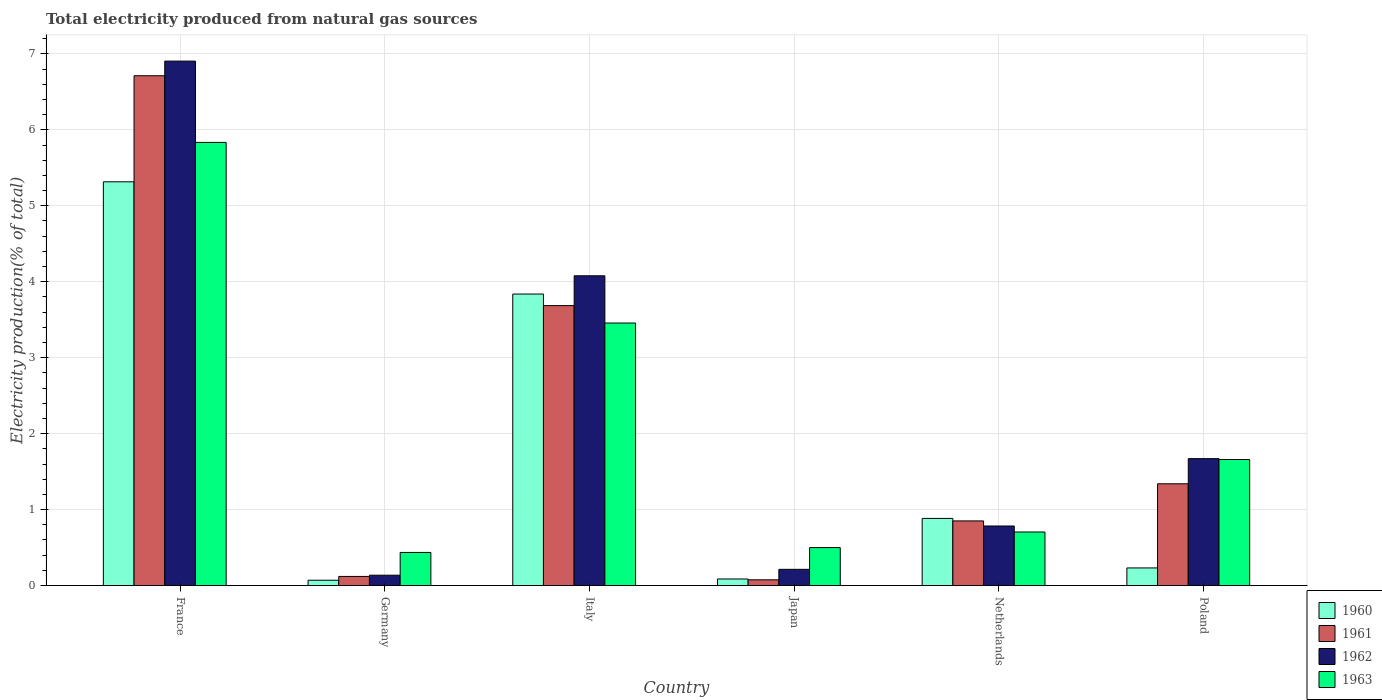How many different coloured bars are there?
Offer a very short reply. 4. Are the number of bars per tick equal to the number of legend labels?
Offer a terse response. Yes. How many bars are there on the 5th tick from the left?
Your response must be concise. 4. How many bars are there on the 1st tick from the right?
Provide a succinct answer. 4. What is the label of the 1st group of bars from the left?
Provide a succinct answer. France. In how many cases, is the number of bars for a given country not equal to the number of legend labels?
Provide a short and direct response. 0. What is the total electricity produced in 1963 in Poland?
Offer a very short reply. 1.66. Across all countries, what is the maximum total electricity produced in 1961?
Provide a short and direct response. 6.71. Across all countries, what is the minimum total electricity produced in 1961?
Provide a succinct answer. 0.08. What is the total total electricity produced in 1961 in the graph?
Provide a succinct answer. 12.78. What is the difference between the total electricity produced in 1960 in Italy and that in Japan?
Offer a terse response. 3.75. What is the difference between the total electricity produced in 1961 in Netherlands and the total electricity produced in 1963 in Germany?
Offer a very short reply. 0.41. What is the average total electricity produced in 1962 per country?
Give a very brief answer. 2.3. What is the difference between the total electricity produced of/in 1960 and total electricity produced of/in 1963 in Italy?
Your answer should be compact. 0.38. In how many countries, is the total electricity produced in 1961 greater than 5 %?
Make the answer very short. 1. What is the ratio of the total electricity produced in 1960 in Germany to that in Japan?
Make the answer very short. 0.81. Is the difference between the total electricity produced in 1960 in Japan and Poland greater than the difference between the total electricity produced in 1963 in Japan and Poland?
Keep it short and to the point. Yes. What is the difference between the highest and the second highest total electricity produced in 1961?
Keep it short and to the point. -2.35. What is the difference between the highest and the lowest total electricity produced in 1963?
Your answer should be compact. 5.4. In how many countries, is the total electricity produced in 1961 greater than the average total electricity produced in 1961 taken over all countries?
Your answer should be very brief. 2. Is the sum of the total electricity produced in 1961 in France and Germany greater than the maximum total electricity produced in 1960 across all countries?
Provide a short and direct response. Yes. Is it the case that in every country, the sum of the total electricity produced in 1962 and total electricity produced in 1961 is greater than the sum of total electricity produced in 1960 and total electricity produced in 1963?
Ensure brevity in your answer.  No. What does the 1st bar from the right in France represents?
Your answer should be very brief. 1963. Is it the case that in every country, the sum of the total electricity produced in 1963 and total electricity produced in 1960 is greater than the total electricity produced in 1961?
Offer a very short reply. Yes. How many bars are there?
Give a very brief answer. 24. Are all the bars in the graph horizontal?
Give a very brief answer. No. Does the graph contain grids?
Your answer should be compact. Yes. Where does the legend appear in the graph?
Give a very brief answer. Bottom right. How many legend labels are there?
Offer a very short reply. 4. What is the title of the graph?
Make the answer very short. Total electricity produced from natural gas sources. Does "1961" appear as one of the legend labels in the graph?
Ensure brevity in your answer.  Yes. What is the label or title of the Y-axis?
Offer a terse response. Electricity production(% of total). What is the Electricity production(% of total) of 1960 in France?
Your response must be concise. 5.32. What is the Electricity production(% of total) of 1961 in France?
Offer a terse response. 6.71. What is the Electricity production(% of total) in 1962 in France?
Offer a terse response. 6.91. What is the Electricity production(% of total) of 1963 in France?
Provide a short and direct response. 5.83. What is the Electricity production(% of total) in 1960 in Germany?
Provide a succinct answer. 0.07. What is the Electricity production(% of total) in 1961 in Germany?
Keep it short and to the point. 0.12. What is the Electricity production(% of total) in 1962 in Germany?
Offer a very short reply. 0.14. What is the Electricity production(% of total) of 1963 in Germany?
Keep it short and to the point. 0.44. What is the Electricity production(% of total) of 1960 in Italy?
Keep it short and to the point. 3.84. What is the Electricity production(% of total) in 1961 in Italy?
Your response must be concise. 3.69. What is the Electricity production(% of total) in 1962 in Italy?
Offer a terse response. 4.08. What is the Electricity production(% of total) in 1963 in Italy?
Make the answer very short. 3.46. What is the Electricity production(% of total) in 1960 in Japan?
Keep it short and to the point. 0.09. What is the Electricity production(% of total) in 1961 in Japan?
Provide a short and direct response. 0.08. What is the Electricity production(% of total) of 1962 in Japan?
Give a very brief answer. 0.21. What is the Electricity production(% of total) in 1963 in Japan?
Your answer should be compact. 0.5. What is the Electricity production(% of total) in 1960 in Netherlands?
Your answer should be very brief. 0.88. What is the Electricity production(% of total) of 1961 in Netherlands?
Provide a succinct answer. 0.85. What is the Electricity production(% of total) of 1962 in Netherlands?
Your answer should be compact. 0.78. What is the Electricity production(% of total) in 1963 in Netherlands?
Provide a short and direct response. 0.71. What is the Electricity production(% of total) of 1960 in Poland?
Offer a very short reply. 0.23. What is the Electricity production(% of total) in 1961 in Poland?
Give a very brief answer. 1.34. What is the Electricity production(% of total) of 1962 in Poland?
Keep it short and to the point. 1.67. What is the Electricity production(% of total) in 1963 in Poland?
Give a very brief answer. 1.66. Across all countries, what is the maximum Electricity production(% of total) of 1960?
Give a very brief answer. 5.32. Across all countries, what is the maximum Electricity production(% of total) of 1961?
Make the answer very short. 6.71. Across all countries, what is the maximum Electricity production(% of total) in 1962?
Your answer should be compact. 6.91. Across all countries, what is the maximum Electricity production(% of total) in 1963?
Provide a succinct answer. 5.83. Across all countries, what is the minimum Electricity production(% of total) in 1960?
Provide a short and direct response. 0.07. Across all countries, what is the minimum Electricity production(% of total) in 1961?
Provide a short and direct response. 0.08. Across all countries, what is the minimum Electricity production(% of total) in 1962?
Give a very brief answer. 0.14. Across all countries, what is the minimum Electricity production(% of total) in 1963?
Offer a very short reply. 0.44. What is the total Electricity production(% of total) of 1960 in the graph?
Offer a very short reply. 10.43. What is the total Electricity production(% of total) of 1961 in the graph?
Your answer should be very brief. 12.79. What is the total Electricity production(% of total) of 1962 in the graph?
Offer a very short reply. 13.79. What is the total Electricity production(% of total) in 1963 in the graph?
Offer a terse response. 12.59. What is the difference between the Electricity production(% of total) in 1960 in France and that in Germany?
Provide a succinct answer. 5.25. What is the difference between the Electricity production(% of total) in 1961 in France and that in Germany?
Your response must be concise. 6.59. What is the difference between the Electricity production(% of total) of 1962 in France and that in Germany?
Keep it short and to the point. 6.77. What is the difference between the Electricity production(% of total) of 1963 in France and that in Germany?
Your answer should be very brief. 5.4. What is the difference between the Electricity production(% of total) of 1960 in France and that in Italy?
Your response must be concise. 1.48. What is the difference between the Electricity production(% of total) of 1961 in France and that in Italy?
Keep it short and to the point. 3.03. What is the difference between the Electricity production(% of total) of 1962 in France and that in Italy?
Make the answer very short. 2.83. What is the difference between the Electricity production(% of total) in 1963 in France and that in Italy?
Offer a terse response. 2.38. What is the difference between the Electricity production(% of total) of 1960 in France and that in Japan?
Your answer should be compact. 5.23. What is the difference between the Electricity production(% of total) in 1961 in France and that in Japan?
Your answer should be very brief. 6.64. What is the difference between the Electricity production(% of total) in 1962 in France and that in Japan?
Ensure brevity in your answer.  6.69. What is the difference between the Electricity production(% of total) of 1963 in France and that in Japan?
Give a very brief answer. 5.33. What is the difference between the Electricity production(% of total) of 1960 in France and that in Netherlands?
Keep it short and to the point. 4.43. What is the difference between the Electricity production(% of total) of 1961 in France and that in Netherlands?
Make the answer very short. 5.86. What is the difference between the Electricity production(% of total) of 1962 in France and that in Netherlands?
Keep it short and to the point. 6.12. What is the difference between the Electricity production(% of total) in 1963 in France and that in Netherlands?
Your response must be concise. 5.13. What is the difference between the Electricity production(% of total) in 1960 in France and that in Poland?
Your answer should be very brief. 5.08. What is the difference between the Electricity production(% of total) in 1961 in France and that in Poland?
Keep it short and to the point. 5.37. What is the difference between the Electricity production(% of total) in 1962 in France and that in Poland?
Ensure brevity in your answer.  5.23. What is the difference between the Electricity production(% of total) of 1963 in France and that in Poland?
Your answer should be very brief. 4.18. What is the difference between the Electricity production(% of total) of 1960 in Germany and that in Italy?
Your response must be concise. -3.77. What is the difference between the Electricity production(% of total) in 1961 in Germany and that in Italy?
Keep it short and to the point. -3.57. What is the difference between the Electricity production(% of total) of 1962 in Germany and that in Italy?
Your answer should be compact. -3.94. What is the difference between the Electricity production(% of total) of 1963 in Germany and that in Italy?
Make the answer very short. -3.02. What is the difference between the Electricity production(% of total) in 1960 in Germany and that in Japan?
Ensure brevity in your answer.  -0.02. What is the difference between the Electricity production(% of total) of 1961 in Germany and that in Japan?
Provide a short and direct response. 0.04. What is the difference between the Electricity production(% of total) of 1962 in Germany and that in Japan?
Ensure brevity in your answer.  -0.08. What is the difference between the Electricity production(% of total) of 1963 in Germany and that in Japan?
Provide a succinct answer. -0.06. What is the difference between the Electricity production(% of total) of 1960 in Germany and that in Netherlands?
Provide a short and direct response. -0.81. What is the difference between the Electricity production(% of total) of 1961 in Germany and that in Netherlands?
Offer a very short reply. -0.73. What is the difference between the Electricity production(% of total) in 1962 in Germany and that in Netherlands?
Your answer should be very brief. -0.65. What is the difference between the Electricity production(% of total) in 1963 in Germany and that in Netherlands?
Offer a terse response. -0.27. What is the difference between the Electricity production(% of total) of 1960 in Germany and that in Poland?
Your answer should be compact. -0.16. What is the difference between the Electricity production(% of total) of 1961 in Germany and that in Poland?
Your answer should be very brief. -1.22. What is the difference between the Electricity production(% of total) of 1962 in Germany and that in Poland?
Provide a succinct answer. -1.53. What is the difference between the Electricity production(% of total) in 1963 in Germany and that in Poland?
Give a very brief answer. -1.22. What is the difference between the Electricity production(% of total) in 1960 in Italy and that in Japan?
Your answer should be very brief. 3.75. What is the difference between the Electricity production(% of total) in 1961 in Italy and that in Japan?
Your response must be concise. 3.61. What is the difference between the Electricity production(% of total) in 1962 in Italy and that in Japan?
Your response must be concise. 3.86. What is the difference between the Electricity production(% of total) in 1963 in Italy and that in Japan?
Offer a very short reply. 2.96. What is the difference between the Electricity production(% of total) of 1960 in Italy and that in Netherlands?
Give a very brief answer. 2.95. What is the difference between the Electricity production(% of total) of 1961 in Italy and that in Netherlands?
Give a very brief answer. 2.83. What is the difference between the Electricity production(% of total) of 1962 in Italy and that in Netherlands?
Keep it short and to the point. 3.29. What is the difference between the Electricity production(% of total) in 1963 in Italy and that in Netherlands?
Your answer should be very brief. 2.75. What is the difference between the Electricity production(% of total) in 1960 in Italy and that in Poland?
Give a very brief answer. 3.61. What is the difference between the Electricity production(% of total) of 1961 in Italy and that in Poland?
Keep it short and to the point. 2.35. What is the difference between the Electricity production(% of total) in 1962 in Italy and that in Poland?
Ensure brevity in your answer.  2.41. What is the difference between the Electricity production(% of total) of 1963 in Italy and that in Poland?
Give a very brief answer. 1.8. What is the difference between the Electricity production(% of total) in 1960 in Japan and that in Netherlands?
Offer a very short reply. -0.8. What is the difference between the Electricity production(% of total) in 1961 in Japan and that in Netherlands?
Provide a short and direct response. -0.78. What is the difference between the Electricity production(% of total) in 1962 in Japan and that in Netherlands?
Your response must be concise. -0.57. What is the difference between the Electricity production(% of total) of 1963 in Japan and that in Netherlands?
Offer a terse response. -0.21. What is the difference between the Electricity production(% of total) of 1960 in Japan and that in Poland?
Make the answer very short. -0.15. What is the difference between the Electricity production(% of total) of 1961 in Japan and that in Poland?
Give a very brief answer. -1.26. What is the difference between the Electricity production(% of total) in 1962 in Japan and that in Poland?
Your answer should be compact. -1.46. What is the difference between the Electricity production(% of total) in 1963 in Japan and that in Poland?
Give a very brief answer. -1.16. What is the difference between the Electricity production(% of total) of 1960 in Netherlands and that in Poland?
Give a very brief answer. 0.65. What is the difference between the Electricity production(% of total) of 1961 in Netherlands and that in Poland?
Give a very brief answer. -0.49. What is the difference between the Electricity production(% of total) in 1962 in Netherlands and that in Poland?
Offer a very short reply. -0.89. What is the difference between the Electricity production(% of total) of 1963 in Netherlands and that in Poland?
Keep it short and to the point. -0.95. What is the difference between the Electricity production(% of total) of 1960 in France and the Electricity production(% of total) of 1961 in Germany?
Your response must be concise. 5.2. What is the difference between the Electricity production(% of total) of 1960 in France and the Electricity production(% of total) of 1962 in Germany?
Give a very brief answer. 5.18. What is the difference between the Electricity production(% of total) in 1960 in France and the Electricity production(% of total) in 1963 in Germany?
Keep it short and to the point. 4.88. What is the difference between the Electricity production(% of total) in 1961 in France and the Electricity production(% of total) in 1962 in Germany?
Offer a very short reply. 6.58. What is the difference between the Electricity production(% of total) of 1961 in France and the Electricity production(% of total) of 1963 in Germany?
Keep it short and to the point. 6.28. What is the difference between the Electricity production(% of total) of 1962 in France and the Electricity production(% of total) of 1963 in Germany?
Your answer should be very brief. 6.47. What is the difference between the Electricity production(% of total) in 1960 in France and the Electricity production(% of total) in 1961 in Italy?
Offer a terse response. 1.63. What is the difference between the Electricity production(% of total) in 1960 in France and the Electricity production(% of total) in 1962 in Italy?
Offer a terse response. 1.24. What is the difference between the Electricity production(% of total) in 1960 in France and the Electricity production(% of total) in 1963 in Italy?
Your answer should be very brief. 1.86. What is the difference between the Electricity production(% of total) in 1961 in France and the Electricity production(% of total) in 1962 in Italy?
Keep it short and to the point. 2.63. What is the difference between the Electricity production(% of total) in 1961 in France and the Electricity production(% of total) in 1963 in Italy?
Your answer should be very brief. 3.26. What is the difference between the Electricity production(% of total) of 1962 in France and the Electricity production(% of total) of 1963 in Italy?
Provide a succinct answer. 3.45. What is the difference between the Electricity production(% of total) in 1960 in France and the Electricity production(% of total) in 1961 in Japan?
Ensure brevity in your answer.  5.24. What is the difference between the Electricity production(% of total) of 1960 in France and the Electricity production(% of total) of 1962 in Japan?
Give a very brief answer. 5.1. What is the difference between the Electricity production(% of total) in 1960 in France and the Electricity production(% of total) in 1963 in Japan?
Keep it short and to the point. 4.82. What is the difference between the Electricity production(% of total) of 1961 in France and the Electricity production(% of total) of 1962 in Japan?
Your response must be concise. 6.5. What is the difference between the Electricity production(% of total) of 1961 in France and the Electricity production(% of total) of 1963 in Japan?
Make the answer very short. 6.21. What is the difference between the Electricity production(% of total) of 1962 in France and the Electricity production(% of total) of 1963 in Japan?
Offer a very short reply. 6.4. What is the difference between the Electricity production(% of total) of 1960 in France and the Electricity production(% of total) of 1961 in Netherlands?
Offer a very short reply. 4.46. What is the difference between the Electricity production(% of total) of 1960 in France and the Electricity production(% of total) of 1962 in Netherlands?
Offer a very short reply. 4.53. What is the difference between the Electricity production(% of total) in 1960 in France and the Electricity production(% of total) in 1963 in Netherlands?
Offer a very short reply. 4.61. What is the difference between the Electricity production(% of total) in 1961 in France and the Electricity production(% of total) in 1962 in Netherlands?
Offer a very short reply. 5.93. What is the difference between the Electricity production(% of total) of 1961 in France and the Electricity production(% of total) of 1963 in Netherlands?
Make the answer very short. 6.01. What is the difference between the Electricity production(% of total) in 1962 in France and the Electricity production(% of total) in 1963 in Netherlands?
Your answer should be compact. 6.2. What is the difference between the Electricity production(% of total) in 1960 in France and the Electricity production(% of total) in 1961 in Poland?
Your answer should be compact. 3.98. What is the difference between the Electricity production(% of total) of 1960 in France and the Electricity production(% of total) of 1962 in Poland?
Your response must be concise. 3.64. What is the difference between the Electricity production(% of total) in 1960 in France and the Electricity production(% of total) in 1963 in Poland?
Keep it short and to the point. 3.66. What is the difference between the Electricity production(% of total) in 1961 in France and the Electricity production(% of total) in 1962 in Poland?
Provide a short and direct response. 5.04. What is the difference between the Electricity production(% of total) of 1961 in France and the Electricity production(% of total) of 1963 in Poland?
Make the answer very short. 5.05. What is the difference between the Electricity production(% of total) in 1962 in France and the Electricity production(% of total) in 1963 in Poland?
Your response must be concise. 5.25. What is the difference between the Electricity production(% of total) in 1960 in Germany and the Electricity production(% of total) in 1961 in Italy?
Your response must be concise. -3.62. What is the difference between the Electricity production(% of total) of 1960 in Germany and the Electricity production(% of total) of 1962 in Italy?
Your answer should be very brief. -4.01. What is the difference between the Electricity production(% of total) of 1960 in Germany and the Electricity production(% of total) of 1963 in Italy?
Your answer should be compact. -3.39. What is the difference between the Electricity production(% of total) of 1961 in Germany and the Electricity production(% of total) of 1962 in Italy?
Your answer should be very brief. -3.96. What is the difference between the Electricity production(% of total) of 1961 in Germany and the Electricity production(% of total) of 1963 in Italy?
Your response must be concise. -3.34. What is the difference between the Electricity production(% of total) of 1962 in Germany and the Electricity production(% of total) of 1963 in Italy?
Provide a succinct answer. -3.32. What is the difference between the Electricity production(% of total) in 1960 in Germany and the Electricity production(% of total) in 1961 in Japan?
Provide a succinct answer. -0.01. What is the difference between the Electricity production(% of total) of 1960 in Germany and the Electricity production(% of total) of 1962 in Japan?
Ensure brevity in your answer.  -0.14. What is the difference between the Electricity production(% of total) in 1960 in Germany and the Electricity production(% of total) in 1963 in Japan?
Ensure brevity in your answer.  -0.43. What is the difference between the Electricity production(% of total) of 1961 in Germany and the Electricity production(% of total) of 1962 in Japan?
Give a very brief answer. -0.09. What is the difference between the Electricity production(% of total) in 1961 in Germany and the Electricity production(% of total) in 1963 in Japan?
Your answer should be very brief. -0.38. What is the difference between the Electricity production(% of total) of 1962 in Germany and the Electricity production(% of total) of 1963 in Japan?
Give a very brief answer. -0.36. What is the difference between the Electricity production(% of total) in 1960 in Germany and the Electricity production(% of total) in 1961 in Netherlands?
Make the answer very short. -0.78. What is the difference between the Electricity production(% of total) of 1960 in Germany and the Electricity production(% of total) of 1962 in Netherlands?
Ensure brevity in your answer.  -0.71. What is the difference between the Electricity production(% of total) of 1960 in Germany and the Electricity production(% of total) of 1963 in Netherlands?
Ensure brevity in your answer.  -0.64. What is the difference between the Electricity production(% of total) of 1961 in Germany and the Electricity production(% of total) of 1962 in Netherlands?
Give a very brief answer. -0.66. What is the difference between the Electricity production(% of total) in 1961 in Germany and the Electricity production(% of total) in 1963 in Netherlands?
Your answer should be compact. -0.58. What is the difference between the Electricity production(% of total) in 1962 in Germany and the Electricity production(% of total) in 1963 in Netherlands?
Give a very brief answer. -0.57. What is the difference between the Electricity production(% of total) in 1960 in Germany and the Electricity production(% of total) in 1961 in Poland?
Offer a terse response. -1.27. What is the difference between the Electricity production(% of total) in 1960 in Germany and the Electricity production(% of total) in 1962 in Poland?
Make the answer very short. -1.6. What is the difference between the Electricity production(% of total) of 1960 in Germany and the Electricity production(% of total) of 1963 in Poland?
Keep it short and to the point. -1.59. What is the difference between the Electricity production(% of total) in 1961 in Germany and the Electricity production(% of total) in 1962 in Poland?
Make the answer very short. -1.55. What is the difference between the Electricity production(% of total) of 1961 in Germany and the Electricity production(% of total) of 1963 in Poland?
Provide a succinct answer. -1.54. What is the difference between the Electricity production(% of total) in 1962 in Germany and the Electricity production(% of total) in 1963 in Poland?
Keep it short and to the point. -1.52. What is the difference between the Electricity production(% of total) of 1960 in Italy and the Electricity production(% of total) of 1961 in Japan?
Your response must be concise. 3.76. What is the difference between the Electricity production(% of total) of 1960 in Italy and the Electricity production(% of total) of 1962 in Japan?
Make the answer very short. 3.62. What is the difference between the Electricity production(% of total) of 1960 in Italy and the Electricity production(% of total) of 1963 in Japan?
Your response must be concise. 3.34. What is the difference between the Electricity production(% of total) in 1961 in Italy and the Electricity production(% of total) in 1962 in Japan?
Your response must be concise. 3.47. What is the difference between the Electricity production(% of total) of 1961 in Italy and the Electricity production(% of total) of 1963 in Japan?
Provide a succinct answer. 3.19. What is the difference between the Electricity production(% of total) in 1962 in Italy and the Electricity production(% of total) in 1963 in Japan?
Ensure brevity in your answer.  3.58. What is the difference between the Electricity production(% of total) of 1960 in Italy and the Electricity production(% of total) of 1961 in Netherlands?
Your answer should be very brief. 2.99. What is the difference between the Electricity production(% of total) of 1960 in Italy and the Electricity production(% of total) of 1962 in Netherlands?
Offer a very short reply. 3.05. What is the difference between the Electricity production(% of total) in 1960 in Italy and the Electricity production(% of total) in 1963 in Netherlands?
Provide a succinct answer. 3.13. What is the difference between the Electricity production(% of total) of 1961 in Italy and the Electricity production(% of total) of 1962 in Netherlands?
Give a very brief answer. 2.9. What is the difference between the Electricity production(% of total) of 1961 in Italy and the Electricity production(% of total) of 1963 in Netherlands?
Your answer should be very brief. 2.98. What is the difference between the Electricity production(% of total) of 1962 in Italy and the Electricity production(% of total) of 1963 in Netherlands?
Provide a succinct answer. 3.37. What is the difference between the Electricity production(% of total) of 1960 in Italy and the Electricity production(% of total) of 1961 in Poland?
Keep it short and to the point. 2.5. What is the difference between the Electricity production(% of total) of 1960 in Italy and the Electricity production(% of total) of 1962 in Poland?
Ensure brevity in your answer.  2.17. What is the difference between the Electricity production(% of total) of 1960 in Italy and the Electricity production(% of total) of 1963 in Poland?
Offer a terse response. 2.18. What is the difference between the Electricity production(% of total) in 1961 in Italy and the Electricity production(% of total) in 1962 in Poland?
Your response must be concise. 2.01. What is the difference between the Electricity production(% of total) in 1961 in Italy and the Electricity production(% of total) in 1963 in Poland?
Your answer should be very brief. 2.03. What is the difference between the Electricity production(% of total) of 1962 in Italy and the Electricity production(% of total) of 1963 in Poland?
Provide a short and direct response. 2.42. What is the difference between the Electricity production(% of total) of 1960 in Japan and the Electricity production(% of total) of 1961 in Netherlands?
Offer a terse response. -0.76. What is the difference between the Electricity production(% of total) of 1960 in Japan and the Electricity production(% of total) of 1962 in Netherlands?
Offer a very short reply. -0.7. What is the difference between the Electricity production(% of total) in 1960 in Japan and the Electricity production(% of total) in 1963 in Netherlands?
Your answer should be compact. -0.62. What is the difference between the Electricity production(% of total) in 1961 in Japan and the Electricity production(% of total) in 1962 in Netherlands?
Give a very brief answer. -0.71. What is the difference between the Electricity production(% of total) in 1961 in Japan and the Electricity production(% of total) in 1963 in Netherlands?
Give a very brief answer. -0.63. What is the difference between the Electricity production(% of total) of 1962 in Japan and the Electricity production(% of total) of 1963 in Netherlands?
Give a very brief answer. -0.49. What is the difference between the Electricity production(% of total) of 1960 in Japan and the Electricity production(% of total) of 1961 in Poland?
Your answer should be very brief. -1.25. What is the difference between the Electricity production(% of total) of 1960 in Japan and the Electricity production(% of total) of 1962 in Poland?
Offer a very short reply. -1.58. What is the difference between the Electricity production(% of total) of 1960 in Japan and the Electricity production(% of total) of 1963 in Poland?
Your answer should be very brief. -1.57. What is the difference between the Electricity production(% of total) in 1961 in Japan and the Electricity production(% of total) in 1962 in Poland?
Provide a short and direct response. -1.6. What is the difference between the Electricity production(% of total) of 1961 in Japan and the Electricity production(% of total) of 1963 in Poland?
Offer a terse response. -1.58. What is the difference between the Electricity production(% of total) in 1962 in Japan and the Electricity production(% of total) in 1963 in Poland?
Offer a very short reply. -1.45. What is the difference between the Electricity production(% of total) in 1960 in Netherlands and the Electricity production(% of total) in 1961 in Poland?
Provide a succinct answer. -0.46. What is the difference between the Electricity production(% of total) in 1960 in Netherlands and the Electricity production(% of total) in 1962 in Poland?
Your answer should be compact. -0.79. What is the difference between the Electricity production(% of total) in 1960 in Netherlands and the Electricity production(% of total) in 1963 in Poland?
Offer a very short reply. -0.78. What is the difference between the Electricity production(% of total) in 1961 in Netherlands and the Electricity production(% of total) in 1962 in Poland?
Give a very brief answer. -0.82. What is the difference between the Electricity production(% of total) of 1961 in Netherlands and the Electricity production(% of total) of 1963 in Poland?
Ensure brevity in your answer.  -0.81. What is the difference between the Electricity production(% of total) in 1962 in Netherlands and the Electricity production(% of total) in 1963 in Poland?
Provide a short and direct response. -0.88. What is the average Electricity production(% of total) in 1960 per country?
Give a very brief answer. 1.74. What is the average Electricity production(% of total) in 1961 per country?
Make the answer very short. 2.13. What is the average Electricity production(% of total) of 1962 per country?
Offer a terse response. 2.3. What is the average Electricity production(% of total) of 1963 per country?
Provide a succinct answer. 2.1. What is the difference between the Electricity production(% of total) in 1960 and Electricity production(% of total) in 1961 in France?
Make the answer very short. -1.4. What is the difference between the Electricity production(% of total) of 1960 and Electricity production(% of total) of 1962 in France?
Offer a very short reply. -1.59. What is the difference between the Electricity production(% of total) in 1960 and Electricity production(% of total) in 1963 in France?
Your answer should be very brief. -0.52. What is the difference between the Electricity production(% of total) in 1961 and Electricity production(% of total) in 1962 in France?
Your response must be concise. -0.19. What is the difference between the Electricity production(% of total) in 1961 and Electricity production(% of total) in 1963 in France?
Your answer should be very brief. 0.88. What is the difference between the Electricity production(% of total) of 1962 and Electricity production(% of total) of 1963 in France?
Make the answer very short. 1.07. What is the difference between the Electricity production(% of total) in 1960 and Electricity production(% of total) in 1961 in Germany?
Keep it short and to the point. -0.05. What is the difference between the Electricity production(% of total) of 1960 and Electricity production(% of total) of 1962 in Germany?
Keep it short and to the point. -0.07. What is the difference between the Electricity production(% of total) in 1960 and Electricity production(% of total) in 1963 in Germany?
Keep it short and to the point. -0.37. What is the difference between the Electricity production(% of total) of 1961 and Electricity production(% of total) of 1962 in Germany?
Keep it short and to the point. -0.02. What is the difference between the Electricity production(% of total) in 1961 and Electricity production(% of total) in 1963 in Germany?
Your answer should be very brief. -0.32. What is the difference between the Electricity production(% of total) of 1962 and Electricity production(% of total) of 1963 in Germany?
Make the answer very short. -0.3. What is the difference between the Electricity production(% of total) in 1960 and Electricity production(% of total) in 1961 in Italy?
Offer a terse response. 0.15. What is the difference between the Electricity production(% of total) in 1960 and Electricity production(% of total) in 1962 in Italy?
Provide a short and direct response. -0.24. What is the difference between the Electricity production(% of total) of 1960 and Electricity production(% of total) of 1963 in Italy?
Give a very brief answer. 0.38. What is the difference between the Electricity production(% of total) of 1961 and Electricity production(% of total) of 1962 in Italy?
Offer a very short reply. -0.39. What is the difference between the Electricity production(% of total) of 1961 and Electricity production(% of total) of 1963 in Italy?
Your response must be concise. 0.23. What is the difference between the Electricity production(% of total) of 1962 and Electricity production(% of total) of 1963 in Italy?
Keep it short and to the point. 0.62. What is the difference between the Electricity production(% of total) in 1960 and Electricity production(% of total) in 1961 in Japan?
Provide a succinct answer. 0.01. What is the difference between the Electricity production(% of total) in 1960 and Electricity production(% of total) in 1962 in Japan?
Provide a short and direct response. -0.13. What is the difference between the Electricity production(% of total) of 1960 and Electricity production(% of total) of 1963 in Japan?
Your answer should be very brief. -0.41. What is the difference between the Electricity production(% of total) of 1961 and Electricity production(% of total) of 1962 in Japan?
Give a very brief answer. -0.14. What is the difference between the Electricity production(% of total) of 1961 and Electricity production(% of total) of 1963 in Japan?
Make the answer very short. -0.42. What is the difference between the Electricity production(% of total) in 1962 and Electricity production(% of total) in 1963 in Japan?
Offer a terse response. -0.29. What is the difference between the Electricity production(% of total) in 1960 and Electricity production(% of total) in 1961 in Netherlands?
Offer a very short reply. 0.03. What is the difference between the Electricity production(% of total) in 1960 and Electricity production(% of total) in 1962 in Netherlands?
Ensure brevity in your answer.  0.1. What is the difference between the Electricity production(% of total) of 1960 and Electricity production(% of total) of 1963 in Netherlands?
Your response must be concise. 0.18. What is the difference between the Electricity production(% of total) of 1961 and Electricity production(% of total) of 1962 in Netherlands?
Provide a short and direct response. 0.07. What is the difference between the Electricity production(% of total) in 1961 and Electricity production(% of total) in 1963 in Netherlands?
Provide a succinct answer. 0.15. What is the difference between the Electricity production(% of total) in 1962 and Electricity production(% of total) in 1963 in Netherlands?
Keep it short and to the point. 0.08. What is the difference between the Electricity production(% of total) in 1960 and Electricity production(% of total) in 1961 in Poland?
Your response must be concise. -1.11. What is the difference between the Electricity production(% of total) of 1960 and Electricity production(% of total) of 1962 in Poland?
Ensure brevity in your answer.  -1.44. What is the difference between the Electricity production(% of total) of 1960 and Electricity production(% of total) of 1963 in Poland?
Give a very brief answer. -1.43. What is the difference between the Electricity production(% of total) of 1961 and Electricity production(% of total) of 1962 in Poland?
Provide a short and direct response. -0.33. What is the difference between the Electricity production(% of total) of 1961 and Electricity production(% of total) of 1963 in Poland?
Your response must be concise. -0.32. What is the difference between the Electricity production(% of total) in 1962 and Electricity production(% of total) in 1963 in Poland?
Give a very brief answer. 0.01. What is the ratio of the Electricity production(% of total) in 1960 in France to that in Germany?
Your response must be concise. 75.62. What is the ratio of the Electricity production(% of total) of 1961 in France to that in Germany?
Give a very brief answer. 55.79. What is the ratio of the Electricity production(% of total) of 1962 in France to that in Germany?
Keep it short and to the point. 50.69. What is the ratio of the Electricity production(% of total) in 1963 in France to that in Germany?
Keep it short and to the point. 13.38. What is the ratio of the Electricity production(% of total) of 1960 in France to that in Italy?
Ensure brevity in your answer.  1.39. What is the ratio of the Electricity production(% of total) of 1961 in France to that in Italy?
Your response must be concise. 1.82. What is the ratio of the Electricity production(% of total) of 1962 in France to that in Italy?
Your answer should be compact. 1.69. What is the ratio of the Electricity production(% of total) of 1963 in France to that in Italy?
Make the answer very short. 1.69. What is the ratio of the Electricity production(% of total) of 1960 in France to that in Japan?
Offer a very short reply. 61.4. What is the ratio of the Electricity production(% of total) of 1961 in France to that in Japan?
Your answer should be compact. 88.67. What is the ratio of the Electricity production(% of total) in 1962 in France to that in Japan?
Give a very brief answer. 32.32. What is the ratio of the Electricity production(% of total) in 1963 in France to that in Japan?
Your response must be concise. 11.67. What is the ratio of the Electricity production(% of total) in 1960 in France to that in Netherlands?
Your answer should be compact. 6.01. What is the ratio of the Electricity production(% of total) in 1961 in France to that in Netherlands?
Provide a short and direct response. 7.89. What is the ratio of the Electricity production(% of total) in 1962 in France to that in Netherlands?
Your answer should be very brief. 8.8. What is the ratio of the Electricity production(% of total) of 1963 in France to that in Netherlands?
Give a very brief answer. 8.27. What is the ratio of the Electricity production(% of total) of 1960 in France to that in Poland?
Your answer should be very brief. 22.89. What is the ratio of the Electricity production(% of total) of 1961 in France to that in Poland?
Offer a very short reply. 5.01. What is the ratio of the Electricity production(% of total) of 1962 in France to that in Poland?
Ensure brevity in your answer.  4.13. What is the ratio of the Electricity production(% of total) in 1963 in France to that in Poland?
Give a very brief answer. 3.52. What is the ratio of the Electricity production(% of total) in 1960 in Germany to that in Italy?
Give a very brief answer. 0.02. What is the ratio of the Electricity production(% of total) in 1961 in Germany to that in Italy?
Make the answer very short. 0.03. What is the ratio of the Electricity production(% of total) of 1962 in Germany to that in Italy?
Give a very brief answer. 0.03. What is the ratio of the Electricity production(% of total) of 1963 in Germany to that in Italy?
Your answer should be compact. 0.13. What is the ratio of the Electricity production(% of total) in 1960 in Germany to that in Japan?
Offer a terse response. 0.81. What is the ratio of the Electricity production(% of total) of 1961 in Germany to that in Japan?
Your answer should be very brief. 1.59. What is the ratio of the Electricity production(% of total) of 1962 in Germany to that in Japan?
Keep it short and to the point. 0.64. What is the ratio of the Electricity production(% of total) in 1963 in Germany to that in Japan?
Your answer should be very brief. 0.87. What is the ratio of the Electricity production(% of total) of 1960 in Germany to that in Netherlands?
Keep it short and to the point. 0.08. What is the ratio of the Electricity production(% of total) in 1961 in Germany to that in Netherlands?
Your answer should be compact. 0.14. What is the ratio of the Electricity production(% of total) in 1962 in Germany to that in Netherlands?
Your response must be concise. 0.17. What is the ratio of the Electricity production(% of total) of 1963 in Germany to that in Netherlands?
Ensure brevity in your answer.  0.62. What is the ratio of the Electricity production(% of total) of 1960 in Germany to that in Poland?
Your answer should be compact. 0.3. What is the ratio of the Electricity production(% of total) in 1961 in Germany to that in Poland?
Make the answer very short. 0.09. What is the ratio of the Electricity production(% of total) of 1962 in Germany to that in Poland?
Provide a succinct answer. 0.08. What is the ratio of the Electricity production(% of total) in 1963 in Germany to that in Poland?
Offer a very short reply. 0.26. What is the ratio of the Electricity production(% of total) of 1960 in Italy to that in Japan?
Provide a succinct answer. 44.33. What is the ratio of the Electricity production(% of total) in 1961 in Italy to that in Japan?
Make the answer very short. 48.69. What is the ratio of the Electricity production(% of total) of 1962 in Italy to that in Japan?
Ensure brevity in your answer.  19.09. What is the ratio of the Electricity production(% of total) of 1963 in Italy to that in Japan?
Offer a very short reply. 6.91. What is the ratio of the Electricity production(% of total) of 1960 in Italy to that in Netherlands?
Your answer should be compact. 4.34. What is the ratio of the Electricity production(% of total) in 1961 in Italy to that in Netherlands?
Offer a terse response. 4.33. What is the ratio of the Electricity production(% of total) of 1962 in Italy to that in Netherlands?
Offer a terse response. 5.2. What is the ratio of the Electricity production(% of total) in 1963 in Italy to that in Netherlands?
Provide a succinct answer. 4.9. What is the ratio of the Electricity production(% of total) of 1960 in Italy to that in Poland?
Offer a very short reply. 16.53. What is the ratio of the Electricity production(% of total) of 1961 in Italy to that in Poland?
Ensure brevity in your answer.  2.75. What is the ratio of the Electricity production(% of total) in 1962 in Italy to that in Poland?
Your answer should be very brief. 2.44. What is the ratio of the Electricity production(% of total) in 1963 in Italy to that in Poland?
Offer a very short reply. 2.08. What is the ratio of the Electricity production(% of total) of 1960 in Japan to that in Netherlands?
Offer a very short reply. 0.1. What is the ratio of the Electricity production(% of total) of 1961 in Japan to that in Netherlands?
Your response must be concise. 0.09. What is the ratio of the Electricity production(% of total) of 1962 in Japan to that in Netherlands?
Your answer should be very brief. 0.27. What is the ratio of the Electricity production(% of total) of 1963 in Japan to that in Netherlands?
Keep it short and to the point. 0.71. What is the ratio of the Electricity production(% of total) of 1960 in Japan to that in Poland?
Your answer should be compact. 0.37. What is the ratio of the Electricity production(% of total) of 1961 in Japan to that in Poland?
Keep it short and to the point. 0.06. What is the ratio of the Electricity production(% of total) of 1962 in Japan to that in Poland?
Ensure brevity in your answer.  0.13. What is the ratio of the Electricity production(% of total) of 1963 in Japan to that in Poland?
Ensure brevity in your answer.  0.3. What is the ratio of the Electricity production(% of total) in 1960 in Netherlands to that in Poland?
Your answer should be compact. 3.81. What is the ratio of the Electricity production(% of total) in 1961 in Netherlands to that in Poland?
Ensure brevity in your answer.  0.64. What is the ratio of the Electricity production(% of total) of 1962 in Netherlands to that in Poland?
Your answer should be very brief. 0.47. What is the ratio of the Electricity production(% of total) of 1963 in Netherlands to that in Poland?
Keep it short and to the point. 0.42. What is the difference between the highest and the second highest Electricity production(% of total) in 1960?
Make the answer very short. 1.48. What is the difference between the highest and the second highest Electricity production(% of total) in 1961?
Your answer should be compact. 3.03. What is the difference between the highest and the second highest Electricity production(% of total) in 1962?
Your answer should be compact. 2.83. What is the difference between the highest and the second highest Electricity production(% of total) in 1963?
Provide a short and direct response. 2.38. What is the difference between the highest and the lowest Electricity production(% of total) in 1960?
Offer a terse response. 5.25. What is the difference between the highest and the lowest Electricity production(% of total) of 1961?
Provide a succinct answer. 6.64. What is the difference between the highest and the lowest Electricity production(% of total) of 1962?
Your answer should be very brief. 6.77. What is the difference between the highest and the lowest Electricity production(% of total) of 1963?
Provide a short and direct response. 5.4. 